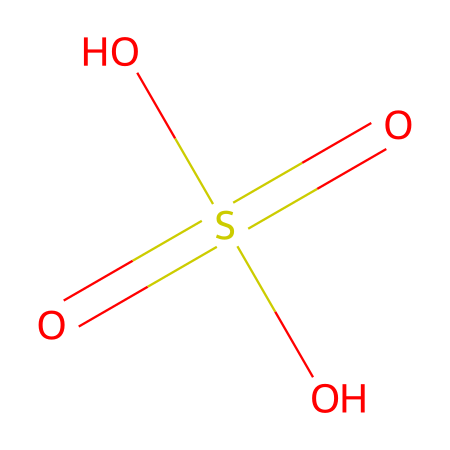What is the oxidation state of the sulfur atom in this molecule? To determine the oxidation state of the sulfur atom, we analyze its connectivity. The sulfur is bonded to four oxygen atoms: one with a double bond (sulfone) and three with single bonds (sulfate). Each oxygen bonded singly contributes a -2 charge, and the double bond does not change the overall charge balance. Thus, the oxidation state of the sulfur must be +6 to ensure the molecule remains neutral, factoring in the -6 from three oxygen atoms and -2 from another oxygen.
Answer: +6 How many oxygen atoms are present in this chemical structure? By closely inspecting the SMILES representation, we can see that there are four distinct oxygen atoms connected to the sulfur atom. Each oxygen is clearly represented in the structure.
Answer: 4 What is the chemical name of this compound based on its structure? The structure exhibited shows a central sulfur atom surrounded by four oxygen species, indicative of a sulfate ion or sulfuric acid derivative. Since it has both single and double bonds to oxygen, the common name is sulfuric acid.
Answer: sulfuric acid What type of ion does this chemical likely form in solution? This chemical, typically sulfuric acid, dissociates in aqueous solution to form hydrogen ions and sulfate ions. The presence of the -SO4 group indicates it will form sulfate ions, which are common in the behavior of acids.
Answer: sulfate ion What is the molecular formula of this compound? From analyzing the elements in the SMILES structure, we can derive that there are two hydrogen atoms, one sulfur atom, and four oxygen atoms. Adding these together gives the molecular formula H2SO4.
Answer: H2SO4 Which part of the molecule is responsible for its acidic properties? The acidic properties of this molecule are primarily due to the presence of the hydrogen ions that can be released from the hydroxyl groups in sulfuric acid, thus indicating the acidic behavior of the compound.
Answer: hydrogen ions 